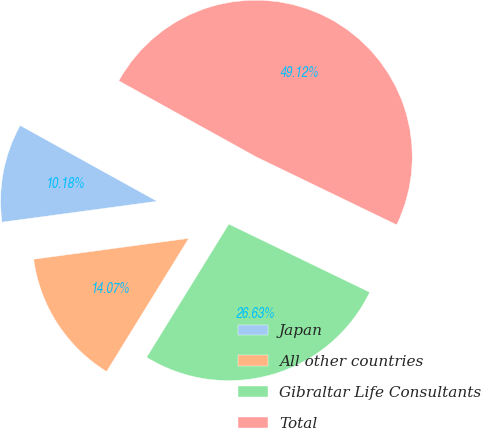Convert chart. <chart><loc_0><loc_0><loc_500><loc_500><pie_chart><fcel>Japan<fcel>All other countries<fcel>Gibraltar Life Consultants<fcel>Total<nl><fcel>10.18%<fcel>14.07%<fcel>26.63%<fcel>49.12%<nl></chart> 